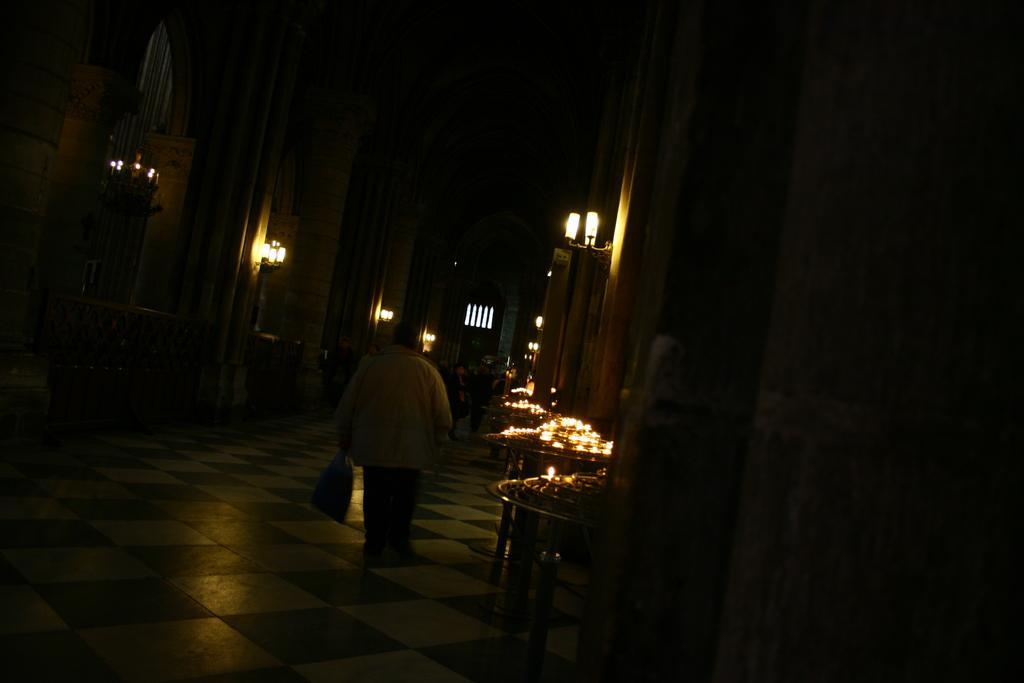Describe this image in one or two sentences. In this image in the center there is one person who is holding a bag and walking. And on the right side there are some tables, on the tables there are some lights and some objects and there is a wall, lamps. In the background there is a window, at the bottom there is floor. 